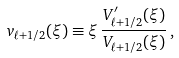<formula> <loc_0><loc_0><loc_500><loc_500>v _ { \ell + 1 / 2 } ( \xi ) \equiv \xi \, \frac { V ^ { \prime } _ { \ell + 1 / 2 } ( \xi ) } { V _ { \ell + 1 / 2 } ( \xi ) } \, ,</formula> 